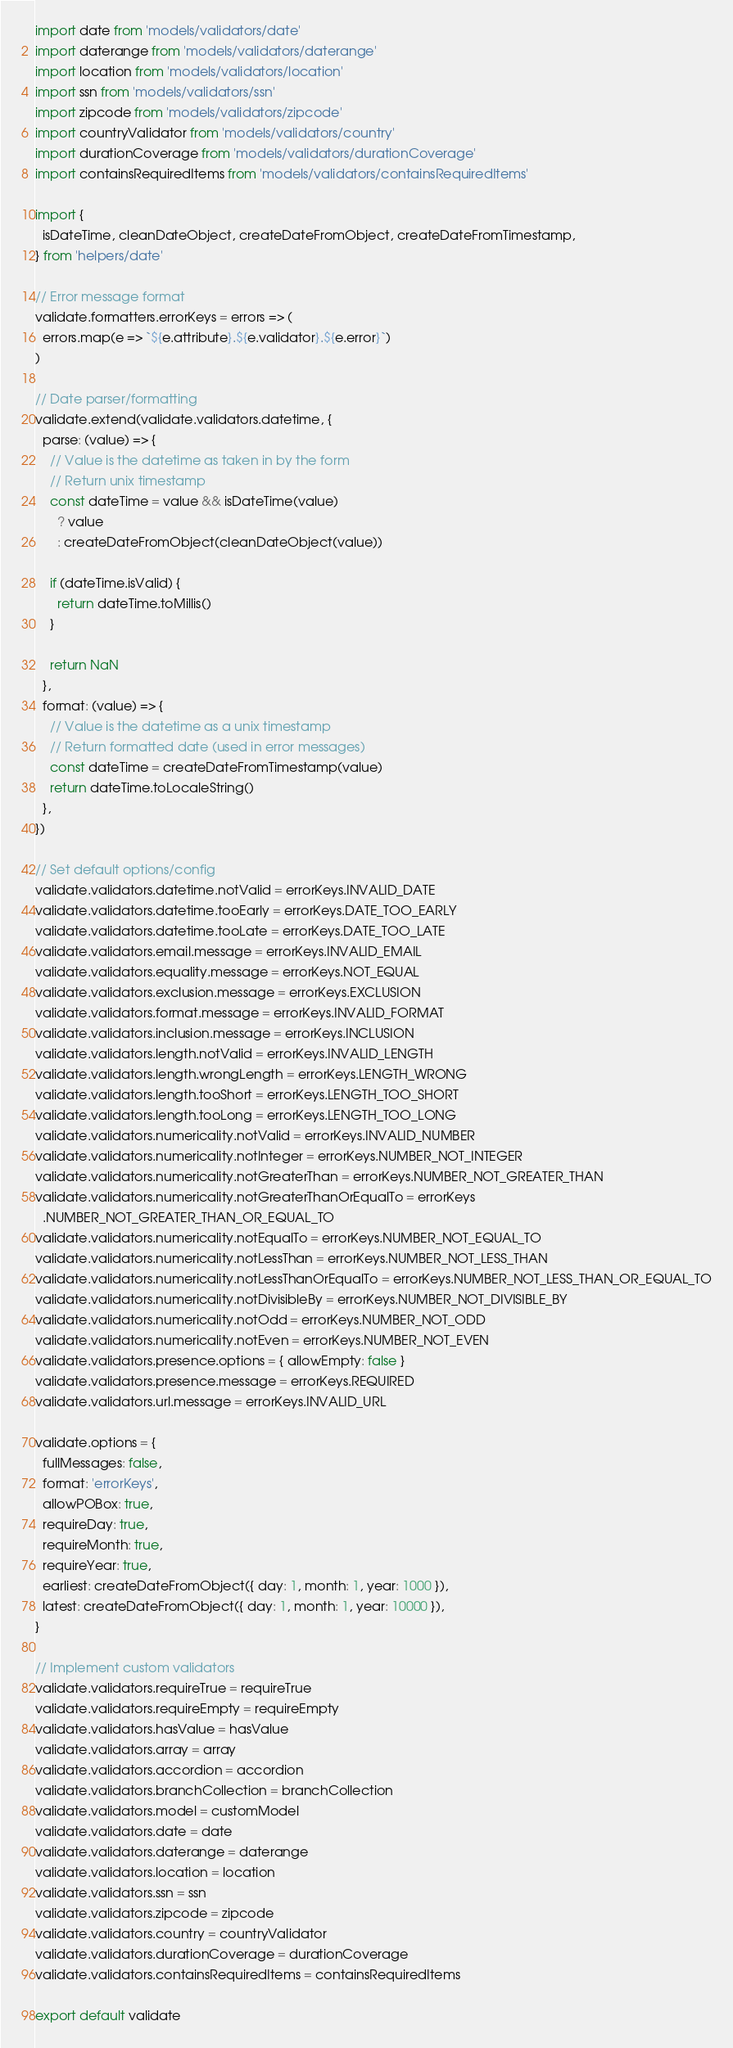Convert code to text. <code><loc_0><loc_0><loc_500><loc_500><_JavaScript_>import date from 'models/validators/date'
import daterange from 'models/validators/daterange'
import location from 'models/validators/location'
import ssn from 'models/validators/ssn'
import zipcode from 'models/validators/zipcode'
import countryValidator from 'models/validators/country'
import durationCoverage from 'models/validators/durationCoverage'
import containsRequiredItems from 'models/validators/containsRequiredItems'

import {
  isDateTime, cleanDateObject, createDateFromObject, createDateFromTimestamp,
} from 'helpers/date'

// Error message format
validate.formatters.errorKeys = errors => (
  errors.map(e => `${e.attribute}.${e.validator}.${e.error}`)
)

// Date parser/formatting
validate.extend(validate.validators.datetime, {
  parse: (value) => {
    // Value is the datetime as taken in by the form
    // Return unix timestamp
    const dateTime = value && isDateTime(value)
      ? value
      : createDateFromObject(cleanDateObject(value))

    if (dateTime.isValid) {
      return dateTime.toMillis()
    }

    return NaN
  },
  format: (value) => {
    // Value is the datetime as a unix timestamp
    // Return formatted date (used in error messages)
    const dateTime = createDateFromTimestamp(value)
    return dateTime.toLocaleString()
  },
})

// Set default options/config
validate.validators.datetime.notValid = errorKeys.INVALID_DATE
validate.validators.datetime.tooEarly = errorKeys.DATE_TOO_EARLY
validate.validators.datetime.tooLate = errorKeys.DATE_TOO_LATE
validate.validators.email.message = errorKeys.INVALID_EMAIL
validate.validators.equality.message = errorKeys.NOT_EQUAL
validate.validators.exclusion.message = errorKeys.EXCLUSION
validate.validators.format.message = errorKeys.INVALID_FORMAT
validate.validators.inclusion.message = errorKeys.INCLUSION
validate.validators.length.notValid = errorKeys.INVALID_LENGTH
validate.validators.length.wrongLength = errorKeys.LENGTH_WRONG
validate.validators.length.tooShort = errorKeys.LENGTH_TOO_SHORT
validate.validators.length.tooLong = errorKeys.LENGTH_TOO_LONG
validate.validators.numericality.notValid = errorKeys.INVALID_NUMBER
validate.validators.numericality.notInteger = errorKeys.NUMBER_NOT_INTEGER
validate.validators.numericality.notGreaterThan = errorKeys.NUMBER_NOT_GREATER_THAN
validate.validators.numericality.notGreaterThanOrEqualTo = errorKeys
  .NUMBER_NOT_GREATER_THAN_OR_EQUAL_TO
validate.validators.numericality.notEqualTo = errorKeys.NUMBER_NOT_EQUAL_TO
validate.validators.numericality.notLessThan = errorKeys.NUMBER_NOT_LESS_THAN
validate.validators.numericality.notLessThanOrEqualTo = errorKeys.NUMBER_NOT_LESS_THAN_OR_EQUAL_TO
validate.validators.numericality.notDivisibleBy = errorKeys.NUMBER_NOT_DIVISIBLE_BY
validate.validators.numericality.notOdd = errorKeys.NUMBER_NOT_ODD
validate.validators.numericality.notEven = errorKeys.NUMBER_NOT_EVEN
validate.validators.presence.options = { allowEmpty: false }
validate.validators.presence.message = errorKeys.REQUIRED
validate.validators.url.message = errorKeys.INVALID_URL

validate.options = {
  fullMessages: false,
  format: 'errorKeys',
  allowPOBox: true,
  requireDay: true,
  requireMonth: true,
  requireYear: true,
  earliest: createDateFromObject({ day: 1, month: 1, year: 1000 }),
  latest: createDateFromObject({ day: 1, month: 1, year: 10000 }),
}

// Implement custom validators
validate.validators.requireTrue = requireTrue
validate.validators.requireEmpty = requireEmpty
validate.validators.hasValue = hasValue
validate.validators.array = array
validate.validators.accordion = accordion
validate.validators.branchCollection = branchCollection
validate.validators.model = customModel
validate.validators.date = date
validate.validators.daterange = daterange
validate.validators.location = location
validate.validators.ssn = ssn
validate.validators.zipcode = zipcode
validate.validators.country = countryValidator
validate.validators.durationCoverage = durationCoverage
validate.validators.containsRequiredItems = containsRequiredItems

export default validate
</code> 